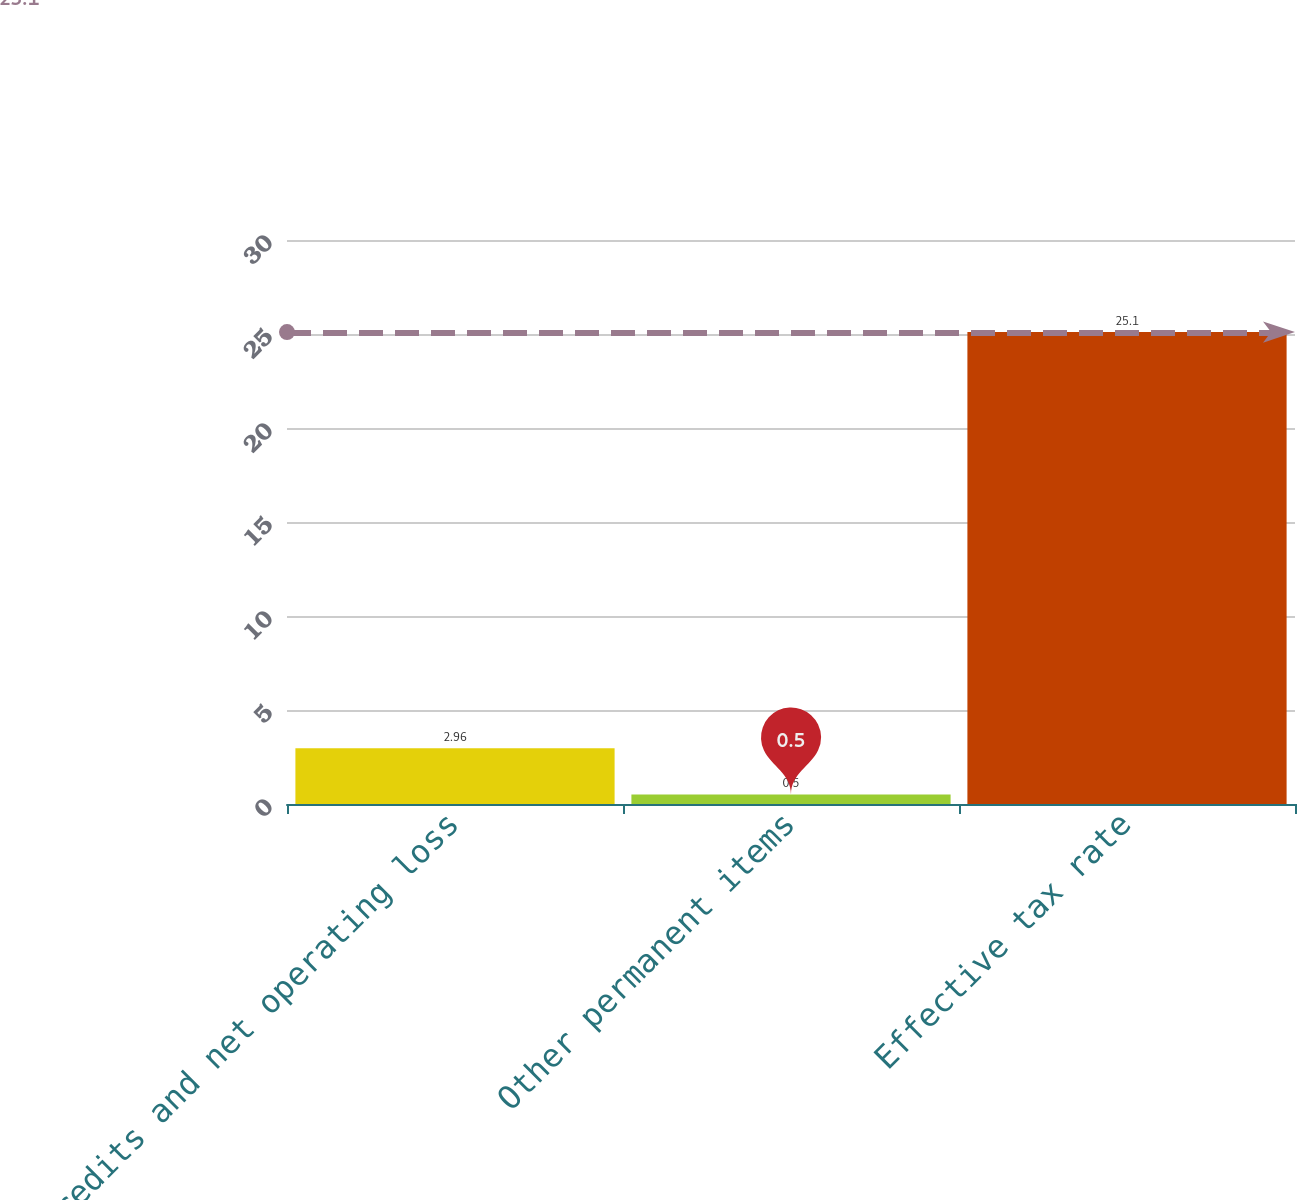<chart> <loc_0><loc_0><loc_500><loc_500><bar_chart><fcel>Credits and net operating loss<fcel>Other permanent items<fcel>Effective tax rate<nl><fcel>2.96<fcel>0.5<fcel>25.1<nl></chart> 